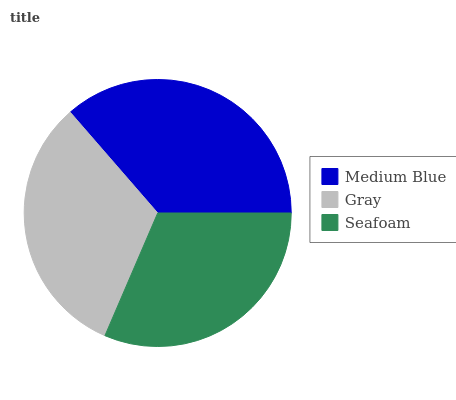Is Seafoam the minimum?
Answer yes or no. Yes. Is Medium Blue the maximum?
Answer yes or no. Yes. Is Gray the minimum?
Answer yes or no. No. Is Gray the maximum?
Answer yes or no. No. Is Medium Blue greater than Gray?
Answer yes or no. Yes. Is Gray less than Medium Blue?
Answer yes or no. Yes. Is Gray greater than Medium Blue?
Answer yes or no. No. Is Medium Blue less than Gray?
Answer yes or no. No. Is Gray the high median?
Answer yes or no. Yes. Is Gray the low median?
Answer yes or no. Yes. Is Seafoam the high median?
Answer yes or no. No. Is Seafoam the low median?
Answer yes or no. No. 